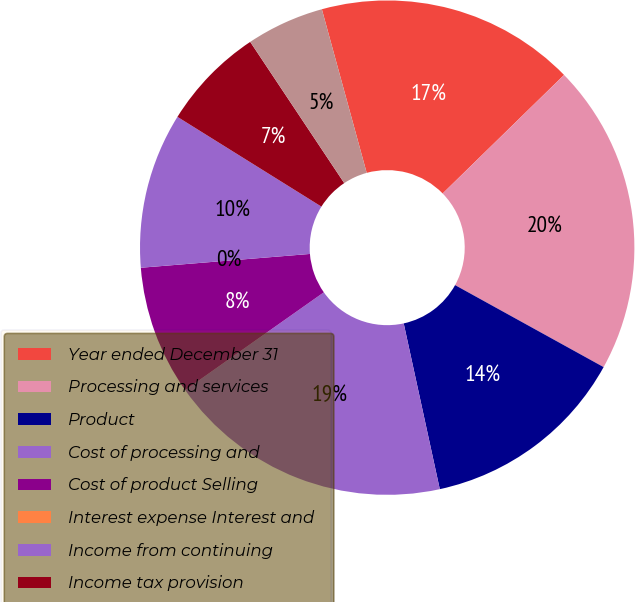Convert chart to OTSL. <chart><loc_0><loc_0><loc_500><loc_500><pie_chart><fcel>Year ended December 31<fcel>Processing and services<fcel>Product<fcel>Cost of processing and<fcel>Cost of product Selling<fcel>Interest expense Interest and<fcel>Income from continuing<fcel>Income tax provision<fcel>Income from investment in<nl><fcel>16.95%<fcel>20.34%<fcel>13.56%<fcel>18.64%<fcel>8.48%<fcel>0.0%<fcel>10.17%<fcel>6.78%<fcel>5.09%<nl></chart> 